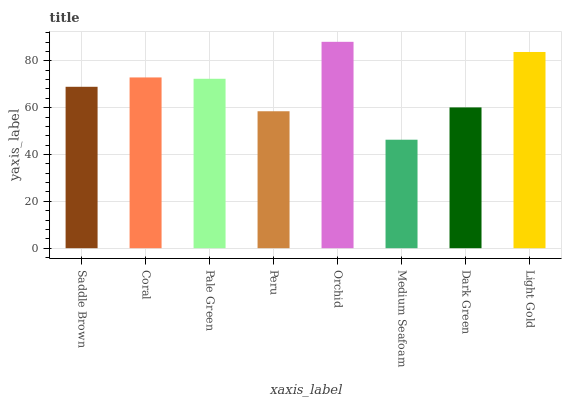Is Medium Seafoam the minimum?
Answer yes or no. Yes. Is Orchid the maximum?
Answer yes or no. Yes. Is Coral the minimum?
Answer yes or no. No. Is Coral the maximum?
Answer yes or no. No. Is Coral greater than Saddle Brown?
Answer yes or no. Yes. Is Saddle Brown less than Coral?
Answer yes or no. Yes. Is Saddle Brown greater than Coral?
Answer yes or no. No. Is Coral less than Saddle Brown?
Answer yes or no. No. Is Pale Green the high median?
Answer yes or no. Yes. Is Saddle Brown the low median?
Answer yes or no. Yes. Is Medium Seafoam the high median?
Answer yes or no. No. Is Coral the low median?
Answer yes or no. No. 